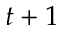Convert formula to latex. <formula><loc_0><loc_0><loc_500><loc_500>t + 1</formula> 